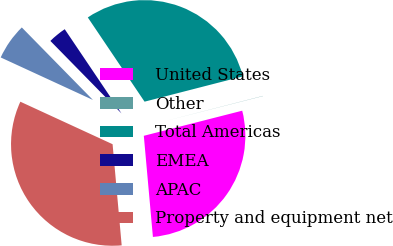<chart> <loc_0><loc_0><loc_500><loc_500><pie_chart><fcel>United States<fcel>Other<fcel>Total Americas<fcel>EMEA<fcel>APAC<fcel>Property and equipment net<nl><fcel>27.55%<fcel>0.03%<fcel>30.43%<fcel>2.91%<fcel>5.78%<fcel>33.3%<nl></chart> 